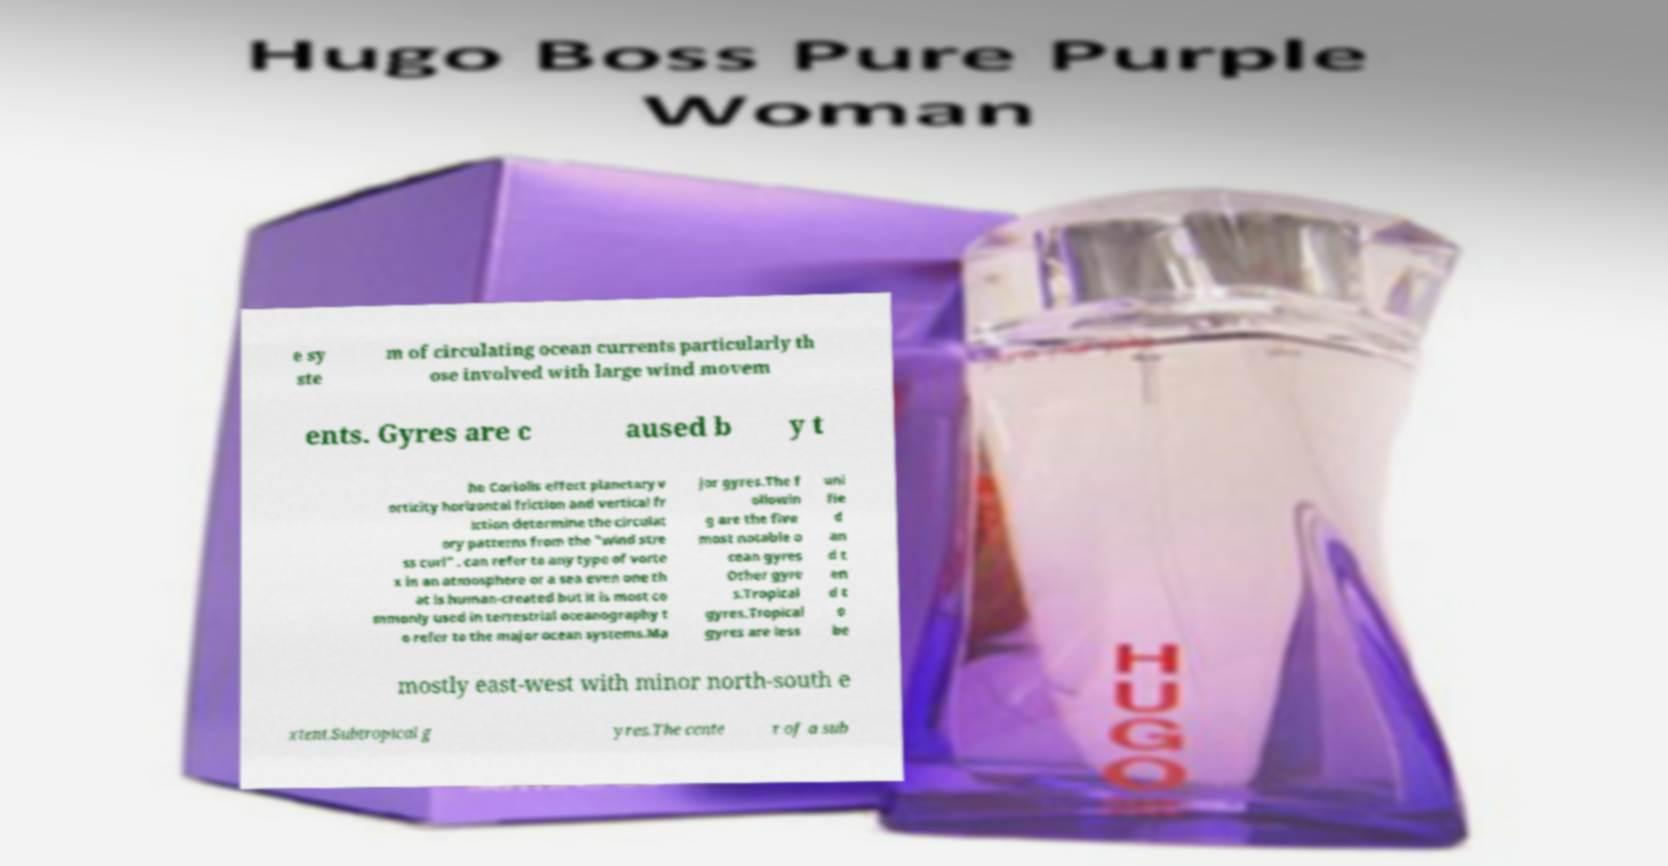Can you read and provide the text displayed in the image?This photo seems to have some interesting text. Can you extract and type it out for me? e sy ste m of circulating ocean currents particularly th ose involved with large wind movem ents. Gyres are c aused b y t he Coriolis effect planetary v orticity horizontal friction and vertical fr iction determine the circulat ory patterns from the "wind stre ss curl" . can refer to any type of vorte x in an atmosphere or a sea even one th at is human-created but it is most co mmonly used in terrestrial oceanography t o refer to the major ocean systems.Ma jor gyres.The f ollowin g are the five most notable o cean gyres Other gyre s.Tropical gyres.Tropical gyres are less uni fie d an d t en d t o be mostly east-west with minor north-south e xtent.Subtropical g yres.The cente r of a sub 